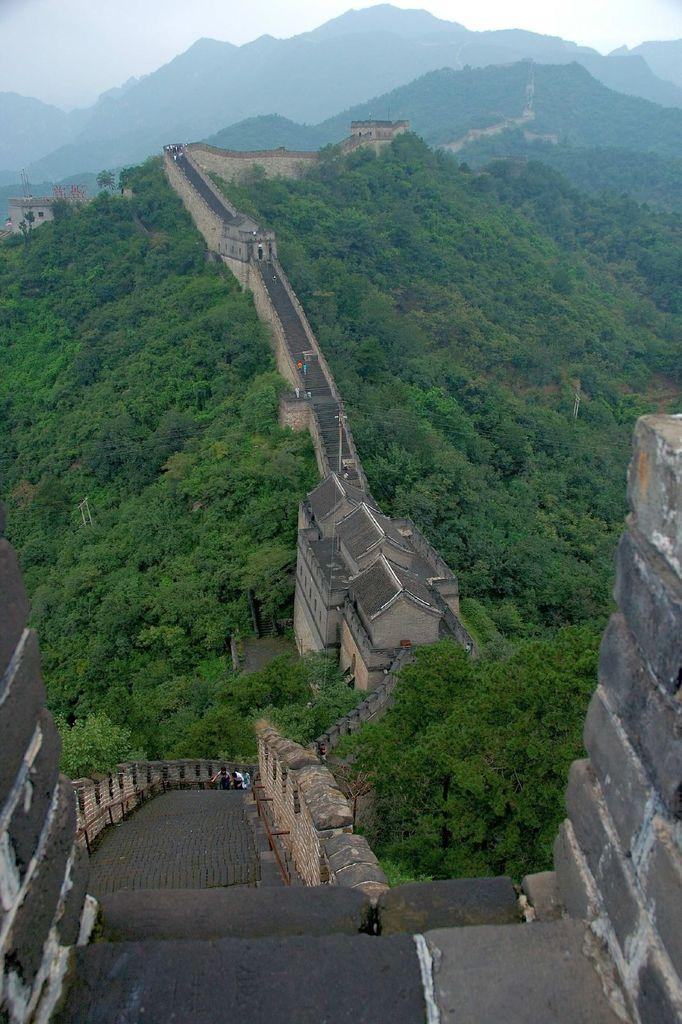What famous landmark can be seen in the image? The Great Wall of China is visible in the image. What type of vegetation is present in the image? There are trees in the image. What natural feature can be seen in the background of the image? Mountains are present in the background of the image. What type of scent can be detected from the image? There is no scent present in the image, as it is a photograph and cannot emit any odors. 